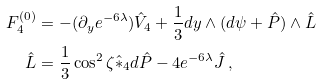<formula> <loc_0><loc_0><loc_500><loc_500>F _ { 4 } ^ { ( 0 ) } & = - ( \partial _ { y } e ^ { - 6 \lambda } ) \hat { V } _ { 4 } + \frac { 1 } { 3 } d y \wedge ( d \psi + \hat { P } ) \wedge \hat { L } \\ \hat { L } & = \frac { 1 } { 3 } \cos ^ { 2 } \zeta \hat { * } _ { 4 } d \hat { P } - 4 e ^ { - 6 \lambda } \hat { J } \, ,</formula> 